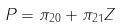Convert formula to latex. <formula><loc_0><loc_0><loc_500><loc_500>P = \pi _ { 2 0 } + \pi _ { 2 1 } Z</formula> 